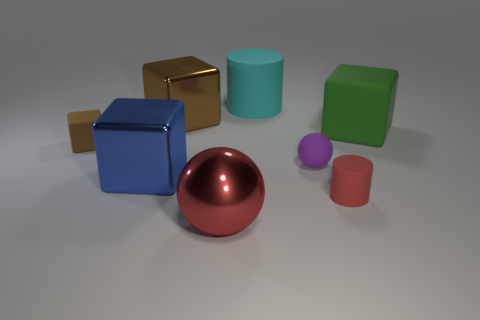Are there fewer blue metal cubes that are right of the cyan cylinder than tiny cubes to the left of the red rubber thing?
Give a very brief answer. Yes. What size is the brown metallic cube?
Keep it short and to the point. Large. What number of big things are brown cubes or yellow rubber objects?
Your answer should be very brief. 1. Does the red metallic thing have the same size as the cube right of the small sphere?
Give a very brief answer. Yes. What number of big gray metal blocks are there?
Your answer should be very brief. 0. How many cyan objects are matte objects or shiny cubes?
Keep it short and to the point. 1. Does the brown thing that is to the right of the tiny cube have the same material as the small red cylinder?
Provide a succinct answer. No. What number of other things are the same material as the small purple sphere?
Offer a terse response. 4. What is the red cylinder made of?
Keep it short and to the point. Rubber. What size is the object to the right of the red matte thing?
Give a very brief answer. Large. 